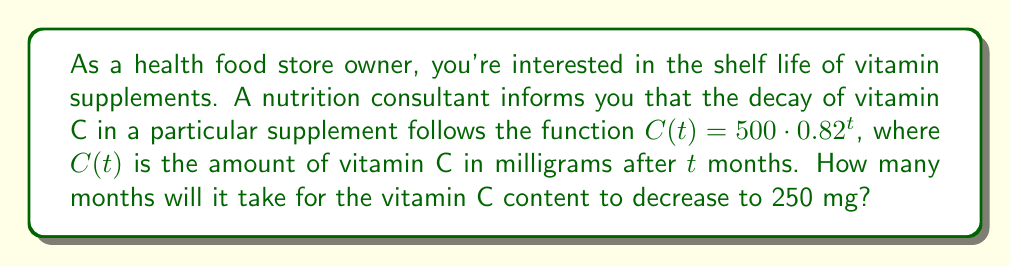Show me your answer to this math problem. To solve this problem, we'll use the logarithmic function to model the vitamin decay rate:

1) We start with the given function: $C(t) = 500 \cdot 0.82^t$

2) We want to find $t$ when $C(t) = 250$ mg. So, we set up the equation:
   $250 = 500 \cdot 0.82^t$

3) Divide both sides by 500:
   $\frac{250}{500} = 0.82^t$
   $0.5 = 0.82^t$

4) To solve for $t$, we need to take the logarithm of both sides. We can use any base, but let's use base 10 for simplicity:
   $\log_{10}(0.5) = \log_{10}(0.82^t)$

5) Using the logarithm property $\log_a(x^n) = n\log_a(x)$, we get:
   $\log_{10}(0.5) = t \cdot \log_{10}(0.82)$

6) Now solve for $t$:
   $t = \frac{\log_{10}(0.5)}{\log_{10}(0.82)}$

7) Use a calculator to evaluate:
   $t \approx \frac{-0.30103}{-0.08619} \approx 3.49$ months

Therefore, it will take approximately 3.49 months for the vitamin C content to decrease to 250 mg.
Answer: $t \approx 3.49$ months 